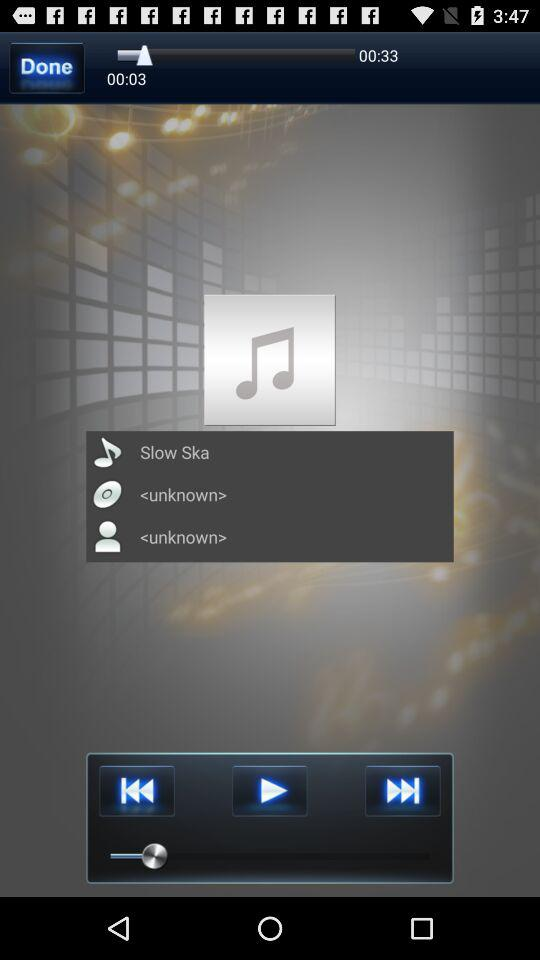What is the length of the song? The length of the song is 33 seconds. 